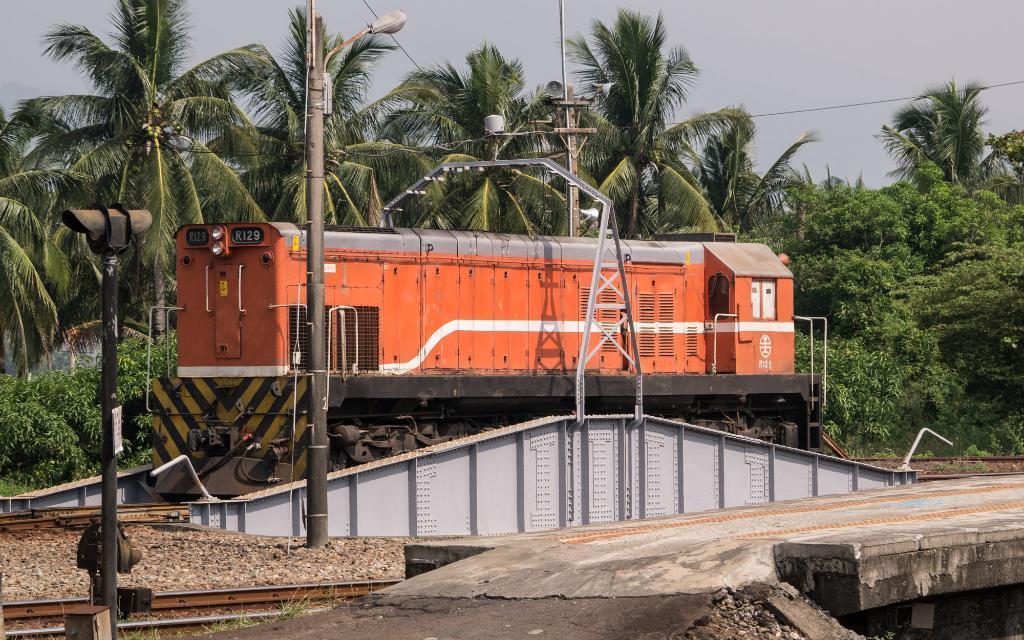Can you describe this image briefly? In this image I can see a railway engine which is orange, grey and white in color on the railway track. I can see few metal poles, few wires and few trees. In the background I can see the sky. 